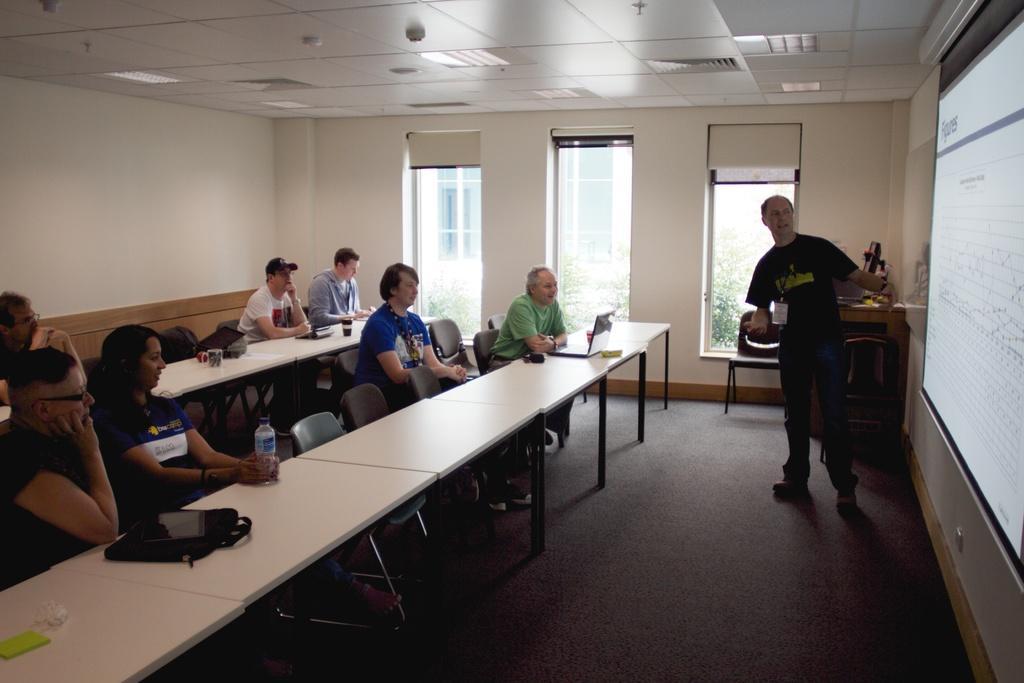Can you describe this image briefly? In this Picture we can see inside view of the seminar hall in which a group of people are sitting on the chairs and white table in front of them. On the right a man wearing black t- shirt is discussing and showing something on the projector screen. Behind we can see the three glass window and on the ceiling ac vents and some fire alarm speakers. 